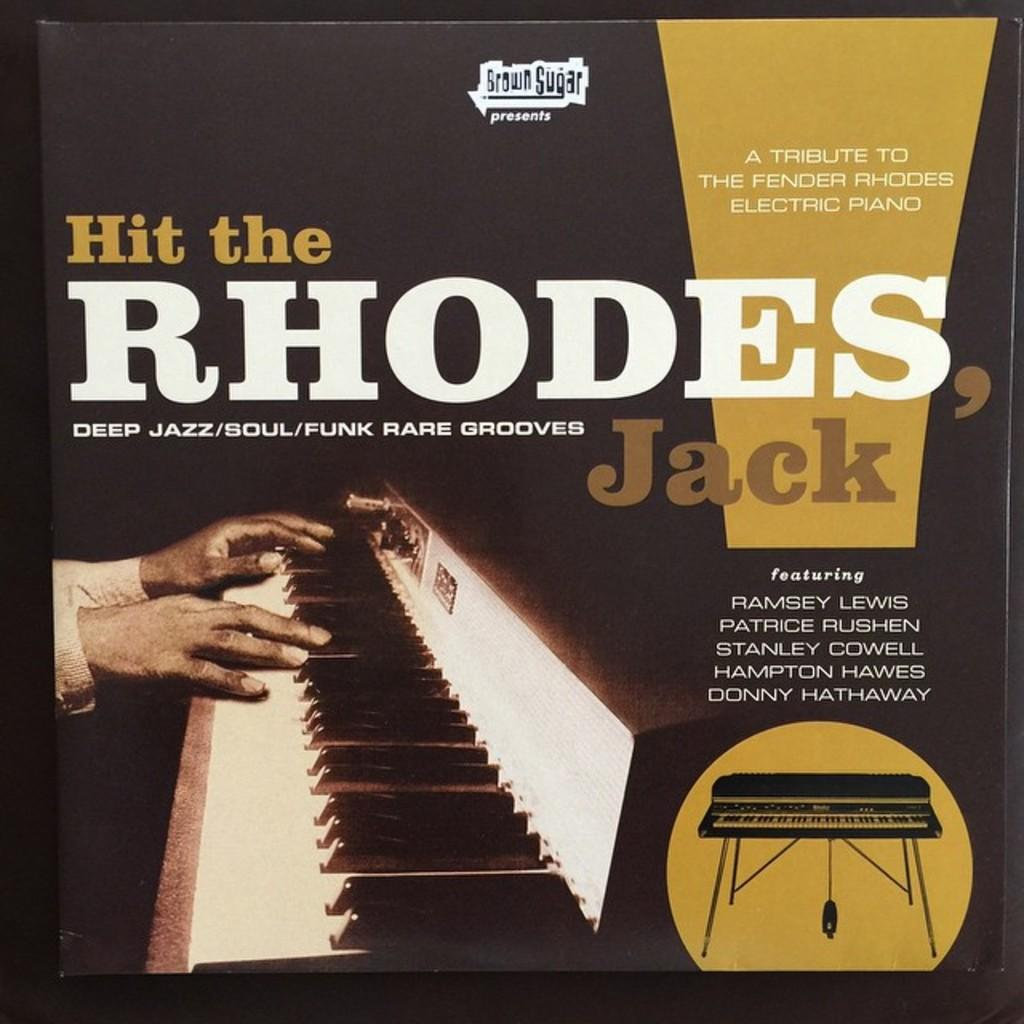What is featured in the image? There is a poster in the image. What can be seen on the poster? There is text on the poster, and there is a piano on the poster. What is happening with the piano on the poster? There are hands on the piano. Can you see a crow sitting on the piano in the image? There is no crow present in the image. Is there a fire burning near the poster in the image? There is no fire present in the image. 